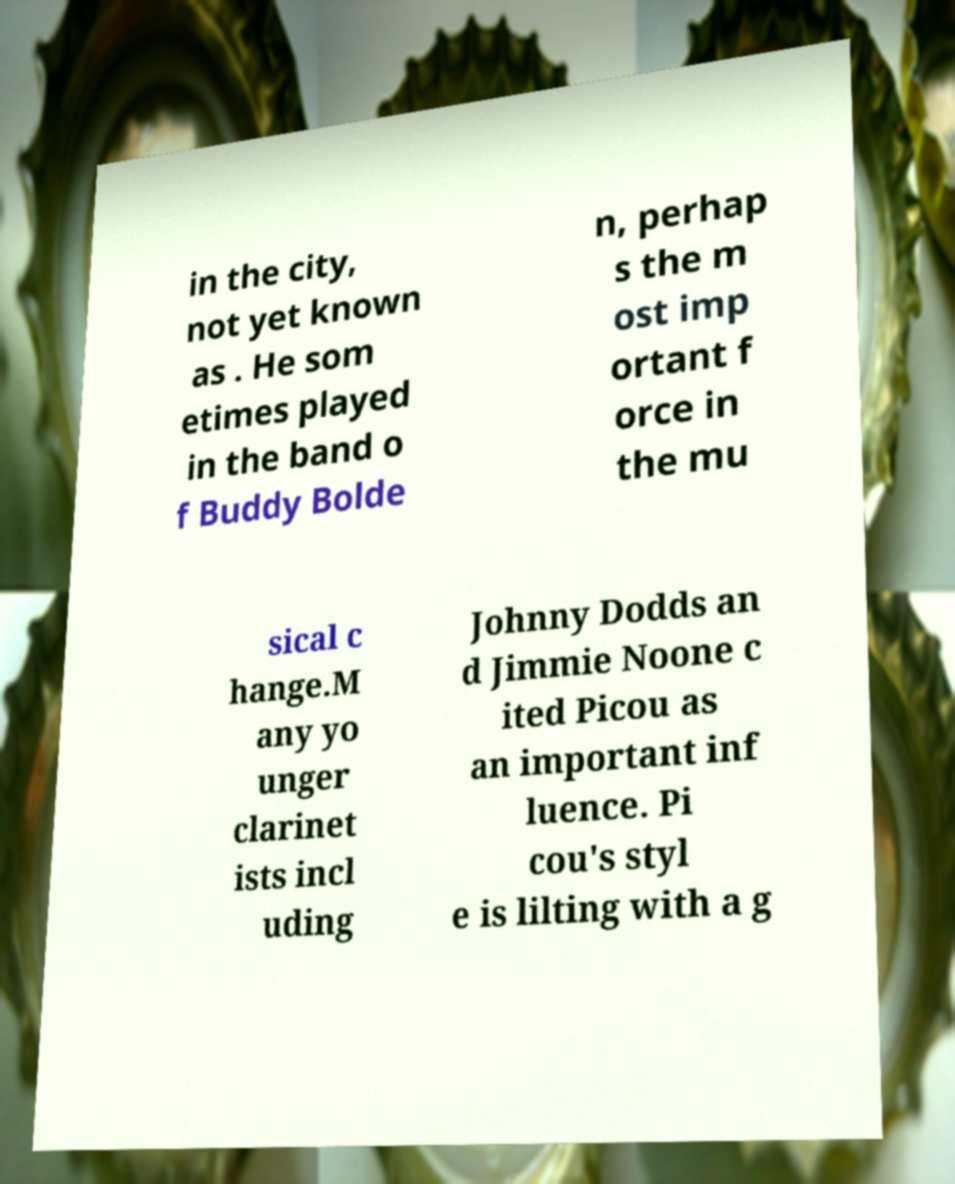For documentation purposes, I need the text within this image transcribed. Could you provide that? in the city, not yet known as . He som etimes played in the band o f Buddy Bolde n, perhap s the m ost imp ortant f orce in the mu sical c hange.M any yo unger clarinet ists incl uding Johnny Dodds an d Jimmie Noone c ited Picou as an important inf luence. Pi cou's styl e is lilting with a g 